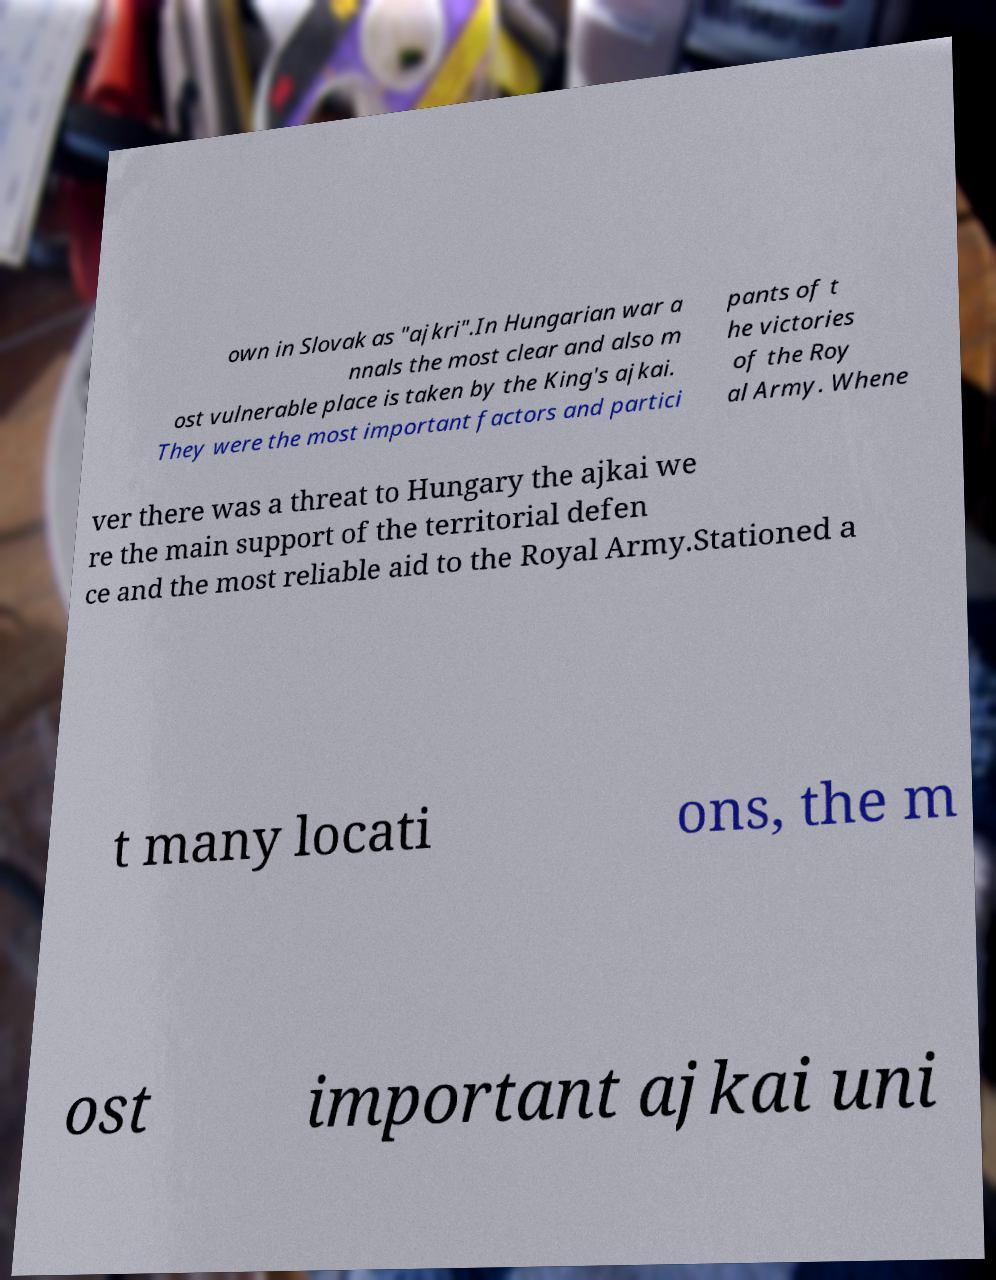There's text embedded in this image that I need extracted. Can you transcribe it verbatim? own in Slovak as "ajkri".In Hungarian war a nnals the most clear and also m ost vulnerable place is taken by the King's ajkai. They were the most important factors and partici pants of t he victories of the Roy al Army. Whene ver there was a threat to Hungary the ajkai we re the main support of the territorial defen ce and the most reliable aid to the Royal Army.Stationed a t many locati ons, the m ost important ajkai uni 